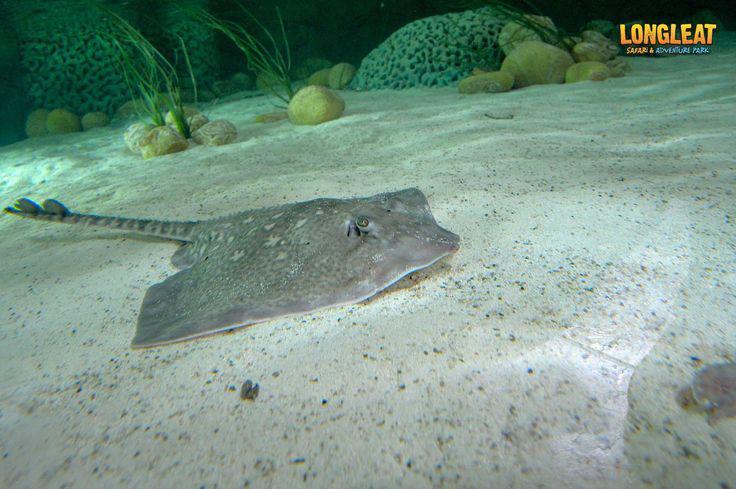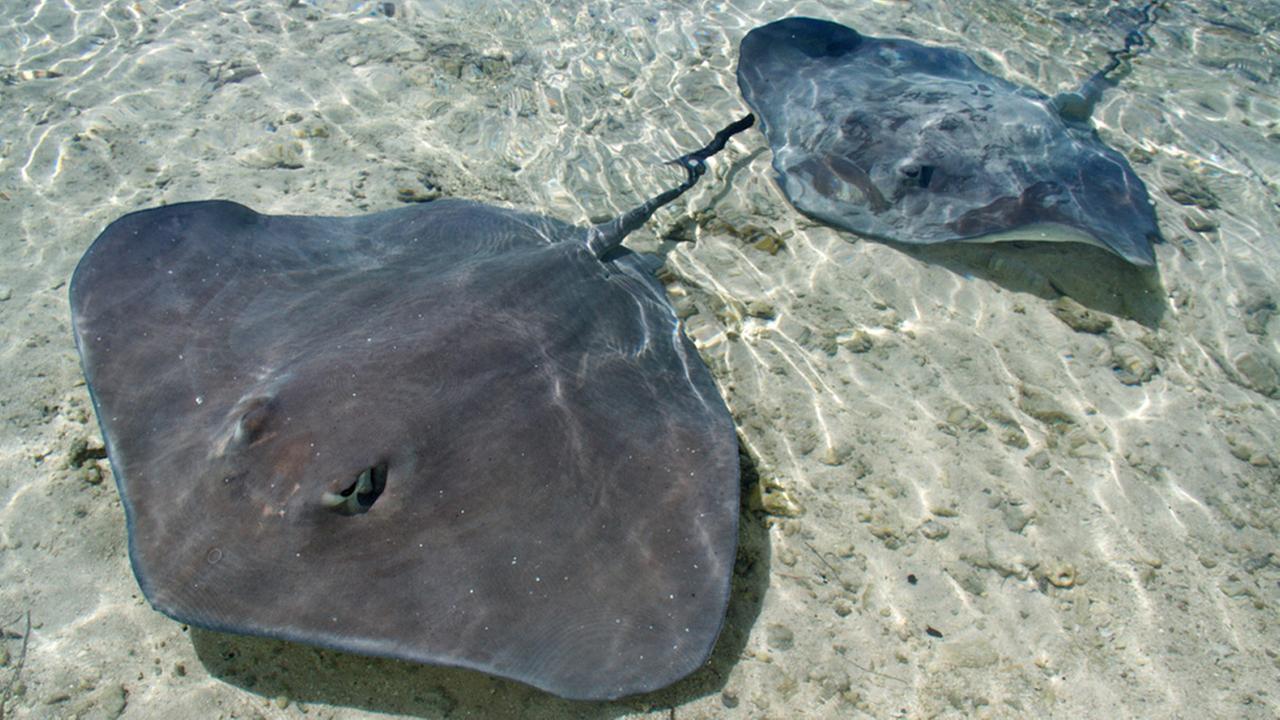The first image is the image on the left, the second image is the image on the right. Examine the images to the left and right. Is the description "The underside of one of the rays in the water is visible in one of the images." accurate? Answer yes or no. No. The first image is the image on the left, the second image is the image on the right. Given the left and right images, does the statement "One stingray with its underside facing the camera is in the foreground of an image." hold true? Answer yes or no. No. 